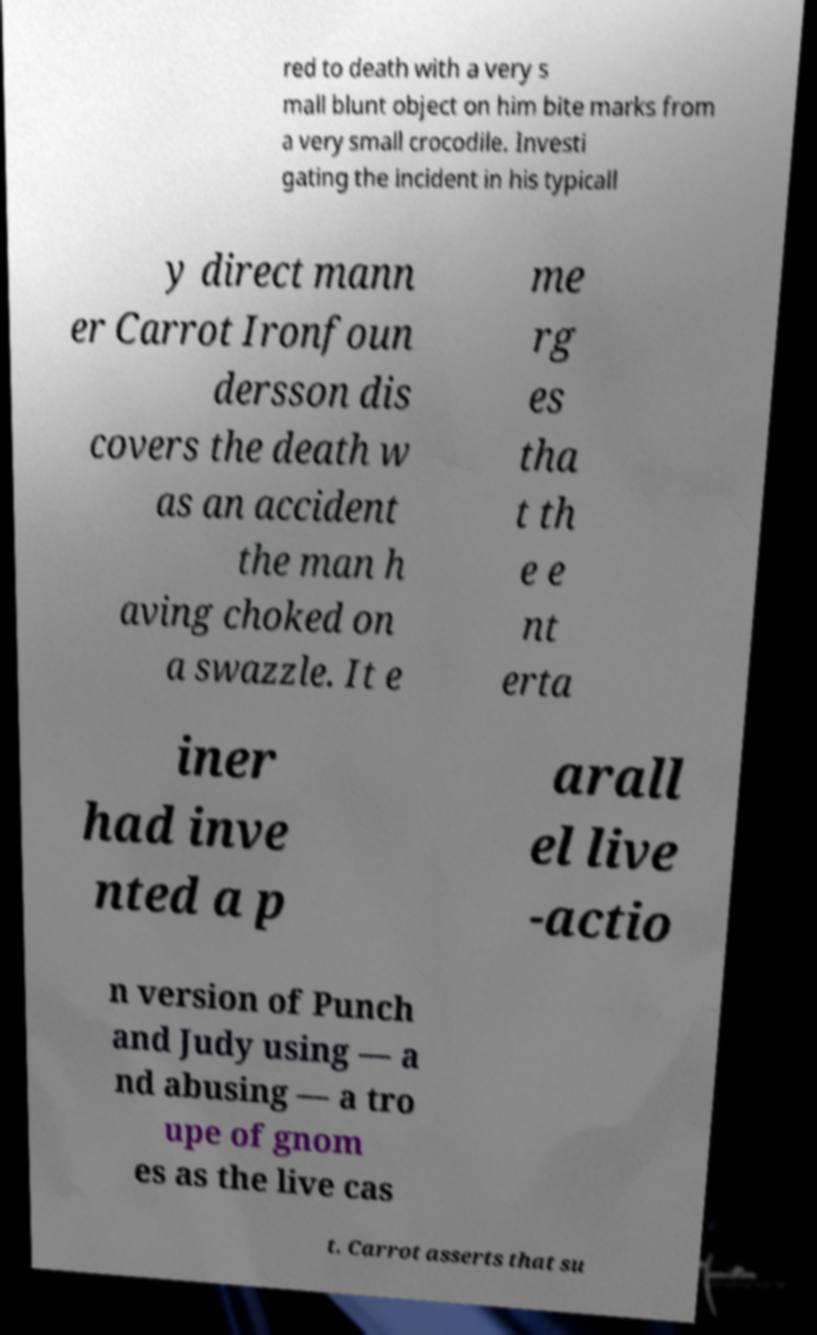There's text embedded in this image that I need extracted. Can you transcribe it verbatim? red to death with a very s mall blunt object on him bite marks from a very small crocodile. Investi gating the incident in his typicall y direct mann er Carrot Ironfoun dersson dis covers the death w as an accident the man h aving choked on a swazzle. It e me rg es tha t th e e nt erta iner had inve nted a p arall el live -actio n version of Punch and Judy using — a nd abusing — a tro upe of gnom es as the live cas t. Carrot asserts that su 